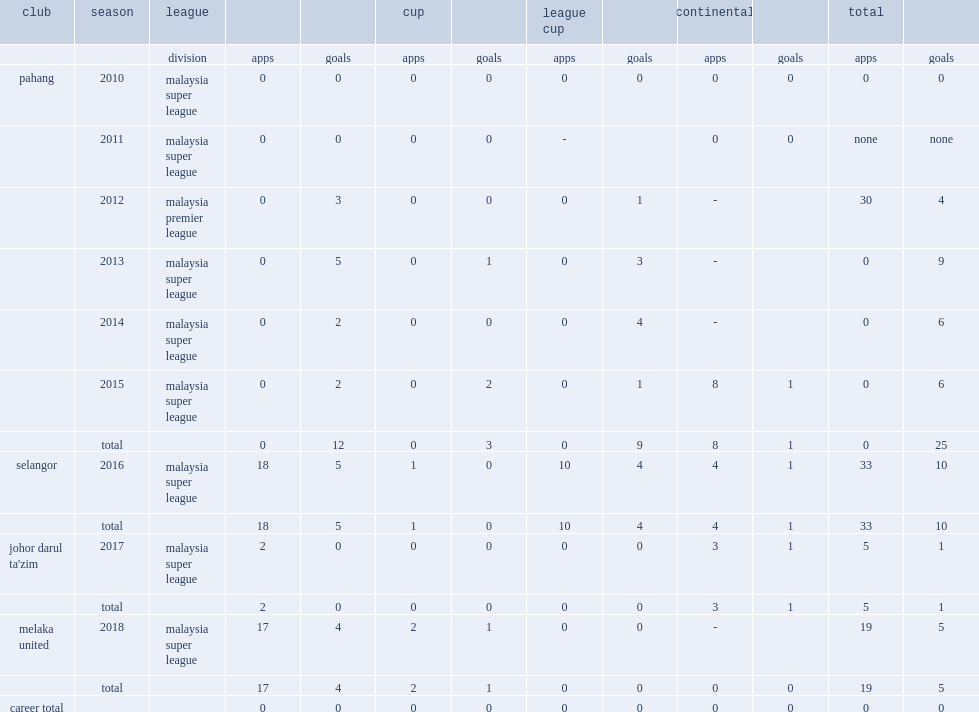How many league goals did gopinathan ramachandra score for pahang in 2012? 3.0. 